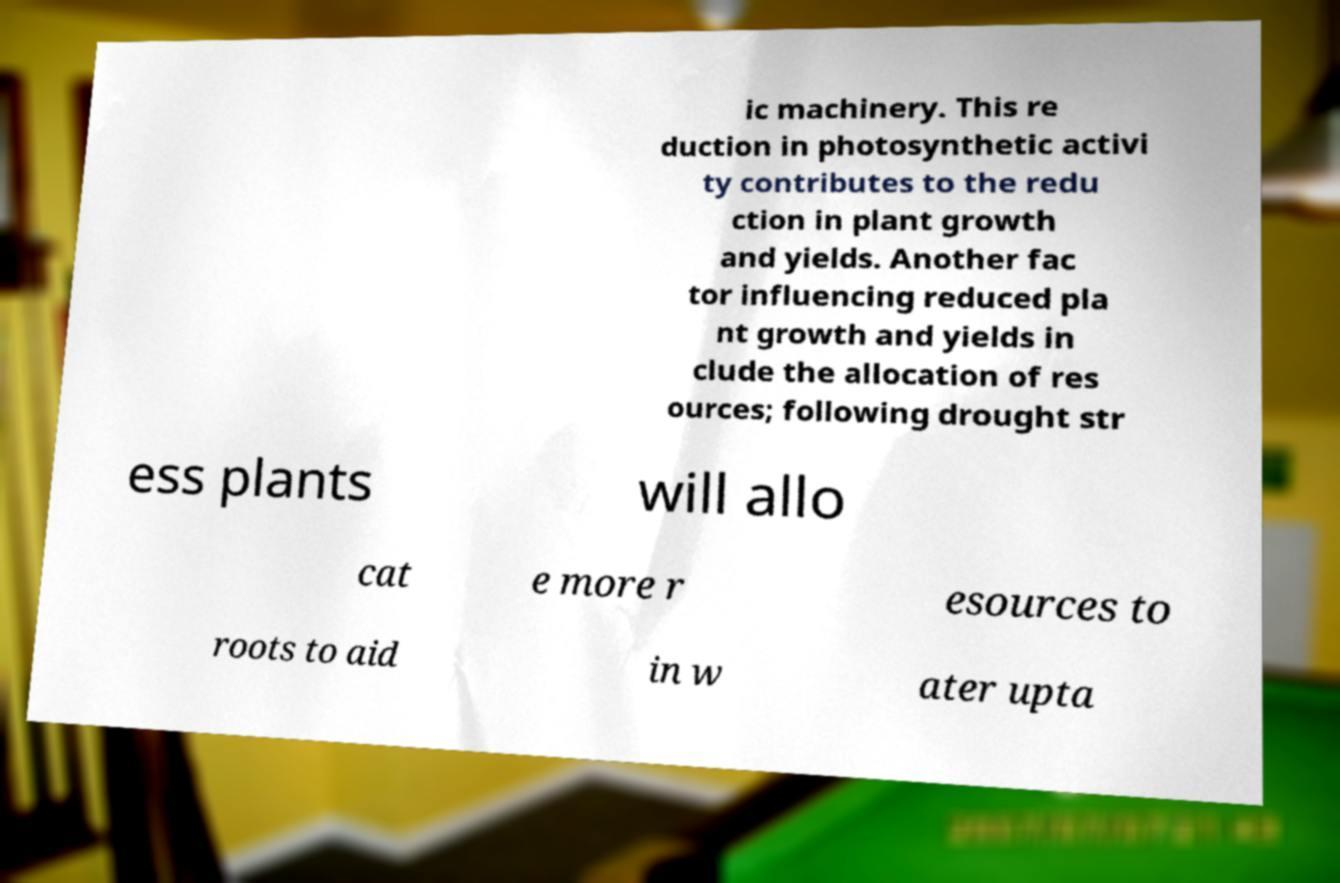There's text embedded in this image that I need extracted. Can you transcribe it verbatim? ic machinery. This re duction in photosynthetic activi ty contributes to the redu ction in plant growth and yields. Another fac tor influencing reduced pla nt growth and yields in clude the allocation of res ources; following drought str ess plants will allo cat e more r esources to roots to aid in w ater upta 